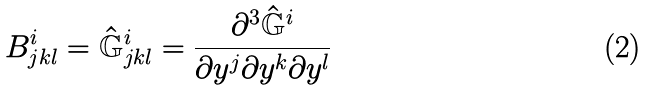<formula> <loc_0><loc_0><loc_500><loc_500>B ^ { i } _ { j k l } = \hat { \mathbb { G } } ^ { i } _ { j k l } = \frac { \partial ^ { 3 } \hat { \mathbb { G } } ^ { i } } { \partial y ^ { j } \partial y ^ { k } \partial y ^ { l } }</formula> 